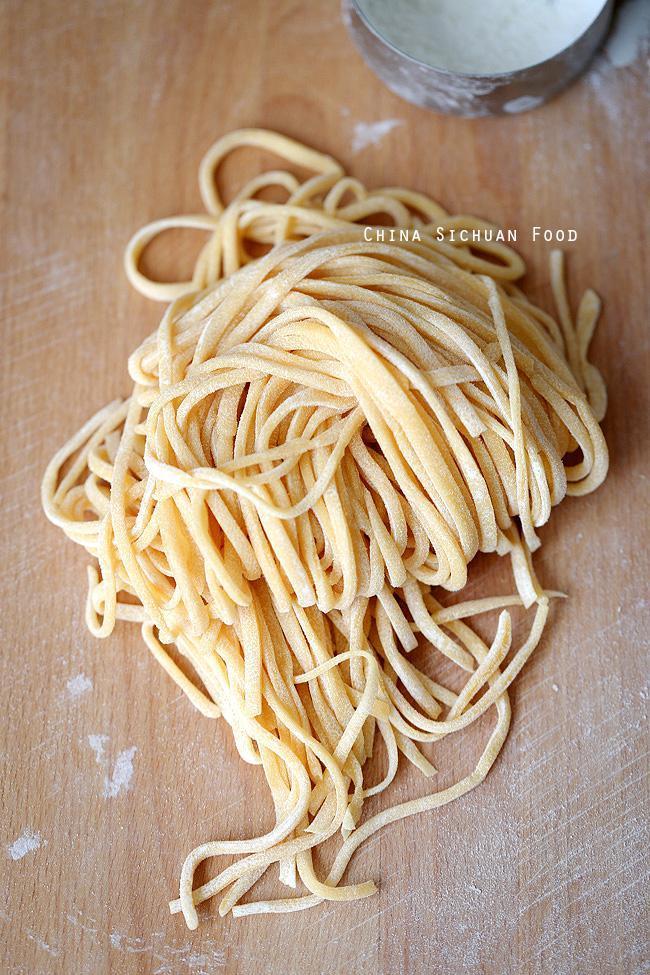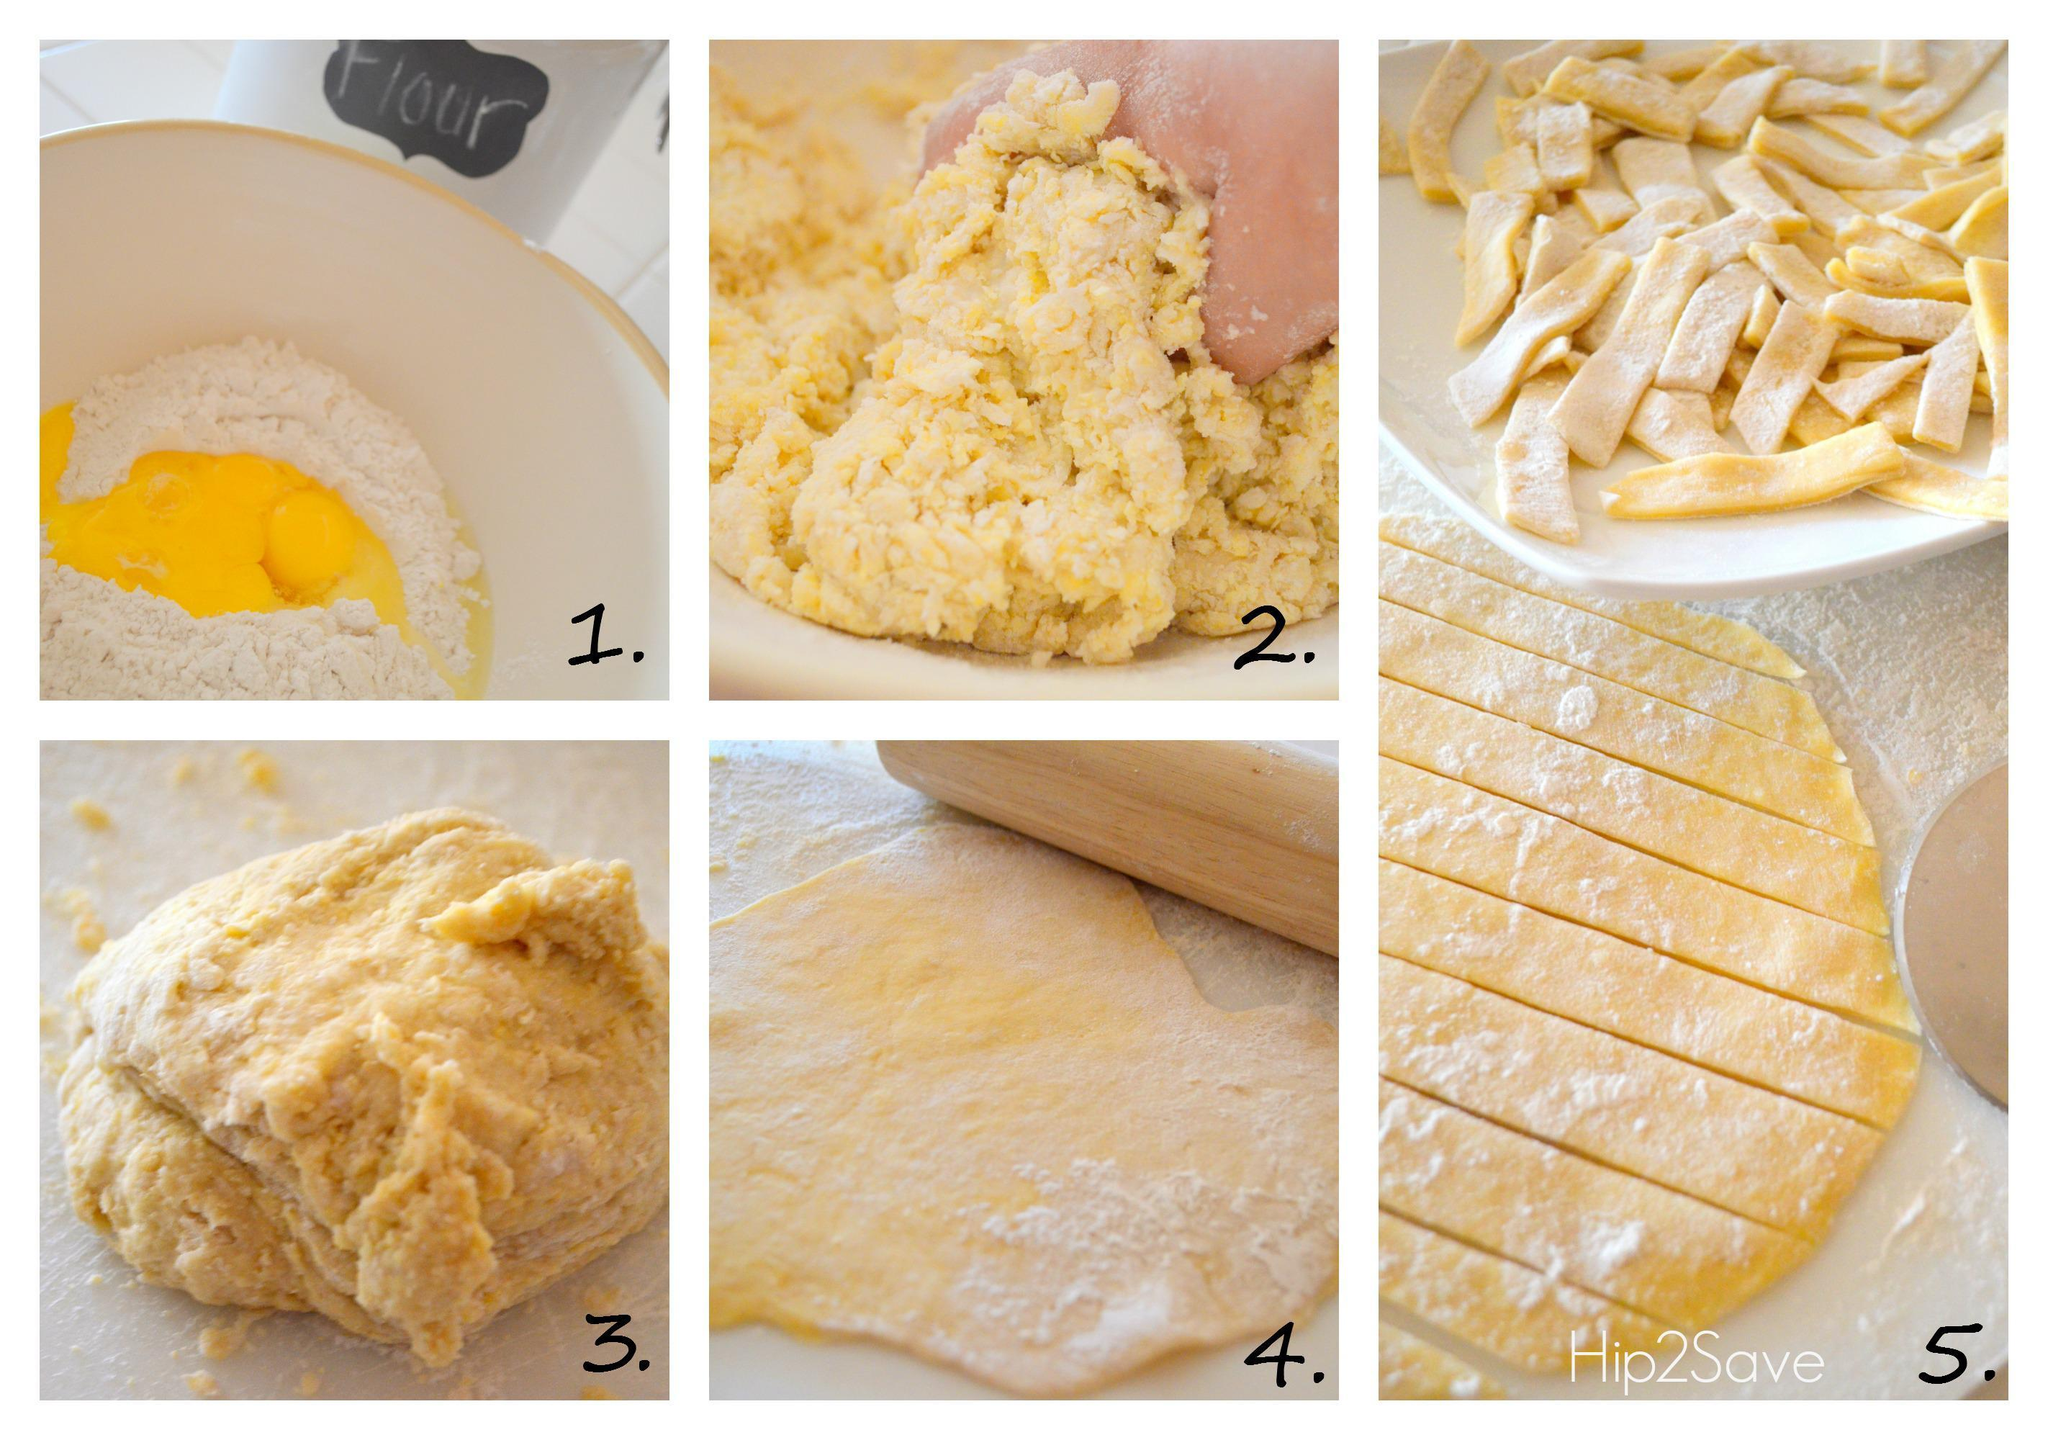The first image is the image on the left, the second image is the image on the right. Examine the images to the left and right. Is the description "Noodles are in a pile on a wood-grain board in one image, and the other image includes raw eggs in the center of white flour in a bowl." accurate? Answer yes or no. Yes. The first image is the image on the left, the second image is the image on the right. Evaluate the accuracy of this statement regarding the images: "One photo shows clearly visible eggs being used as an ingredient and the other image shows completed homemade noodles.". Is it true? Answer yes or no. Yes. 